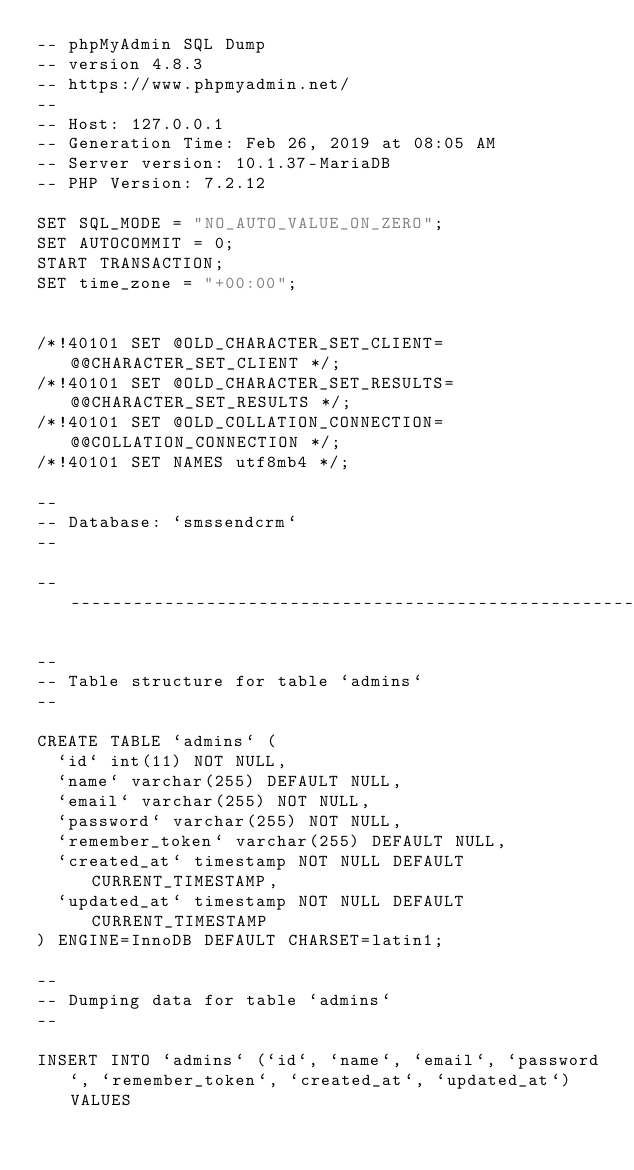Convert code to text. <code><loc_0><loc_0><loc_500><loc_500><_SQL_>-- phpMyAdmin SQL Dump
-- version 4.8.3
-- https://www.phpmyadmin.net/
--
-- Host: 127.0.0.1
-- Generation Time: Feb 26, 2019 at 08:05 AM
-- Server version: 10.1.37-MariaDB
-- PHP Version: 7.2.12

SET SQL_MODE = "NO_AUTO_VALUE_ON_ZERO";
SET AUTOCOMMIT = 0;
START TRANSACTION;
SET time_zone = "+00:00";


/*!40101 SET @OLD_CHARACTER_SET_CLIENT=@@CHARACTER_SET_CLIENT */;
/*!40101 SET @OLD_CHARACTER_SET_RESULTS=@@CHARACTER_SET_RESULTS */;
/*!40101 SET @OLD_COLLATION_CONNECTION=@@COLLATION_CONNECTION */;
/*!40101 SET NAMES utf8mb4 */;

--
-- Database: `smssendcrm`
--

-- --------------------------------------------------------

--
-- Table structure for table `admins`
--

CREATE TABLE `admins` (
  `id` int(11) NOT NULL,
  `name` varchar(255) DEFAULT NULL,
  `email` varchar(255) NOT NULL,
  `password` varchar(255) NOT NULL,
  `remember_token` varchar(255) DEFAULT NULL,
  `created_at` timestamp NOT NULL DEFAULT CURRENT_TIMESTAMP,
  `updated_at` timestamp NOT NULL DEFAULT CURRENT_TIMESTAMP
) ENGINE=InnoDB DEFAULT CHARSET=latin1;

--
-- Dumping data for table `admins`
--

INSERT INTO `admins` (`id`, `name`, `email`, `password`, `remember_token`, `created_at`, `updated_at`) VALUES</code> 